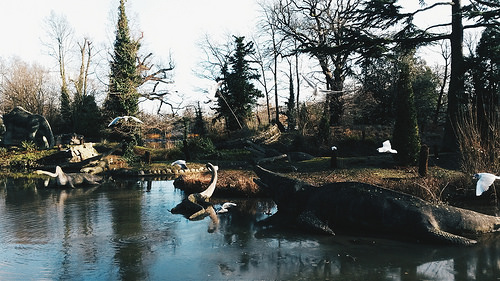<image>
Is the pond next to the bark? Yes. The pond is positioned adjacent to the bark, located nearby in the same general area. 